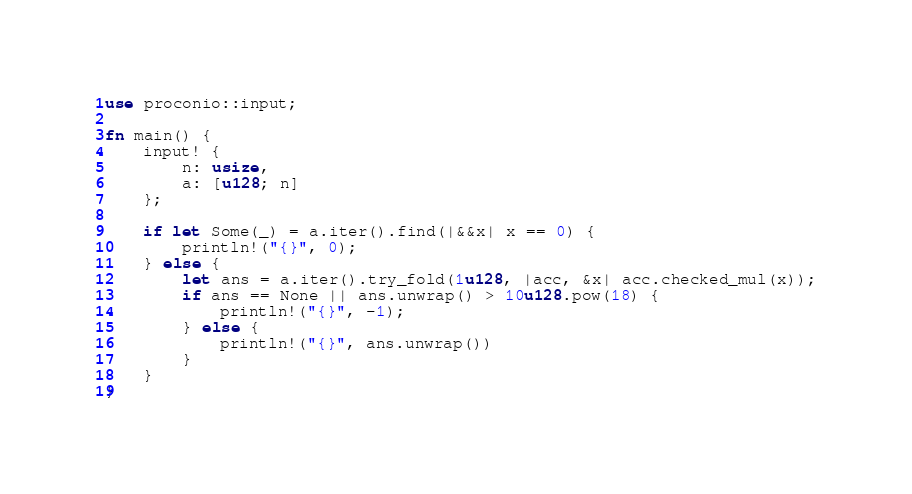Convert code to text. <code><loc_0><loc_0><loc_500><loc_500><_Rust_>use proconio::input;

fn main() {
    input! {
        n: usize,
        a: [u128; n]
    };

    if let Some(_) = a.iter().find(|&&x| x == 0) {
        println!("{}", 0);
    } else {
        let ans = a.iter().try_fold(1u128, |acc, &x| acc.checked_mul(x));
        if ans == None || ans.unwrap() > 10u128.pow(18) {
            println!("{}", -1);
        } else {
            println!("{}", ans.unwrap())
        }
    }
}
</code> 